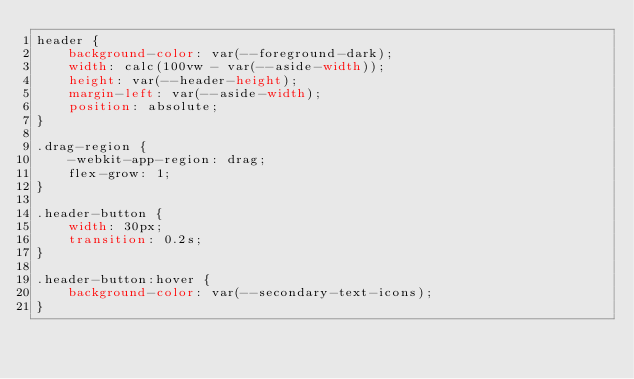Convert code to text. <code><loc_0><loc_0><loc_500><loc_500><_CSS_>header {
    background-color: var(--foreground-dark);
    width: calc(100vw - var(--aside-width));
    height: var(--header-height);
    margin-left: var(--aside-width);
    position: absolute;
}

.drag-region {
    -webkit-app-region: drag;
    flex-grow: 1;
}

.header-button {
    width: 30px;
    transition: 0.2s;
}

.header-button:hover {
    background-color: var(--secondary-text-icons);
}</code> 